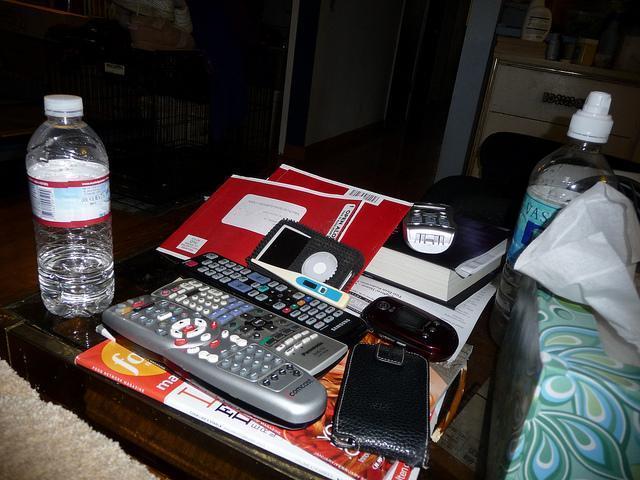How many bottles are there?
Give a very brief answer. 2. How many remotes are there?
Give a very brief answer. 3. 